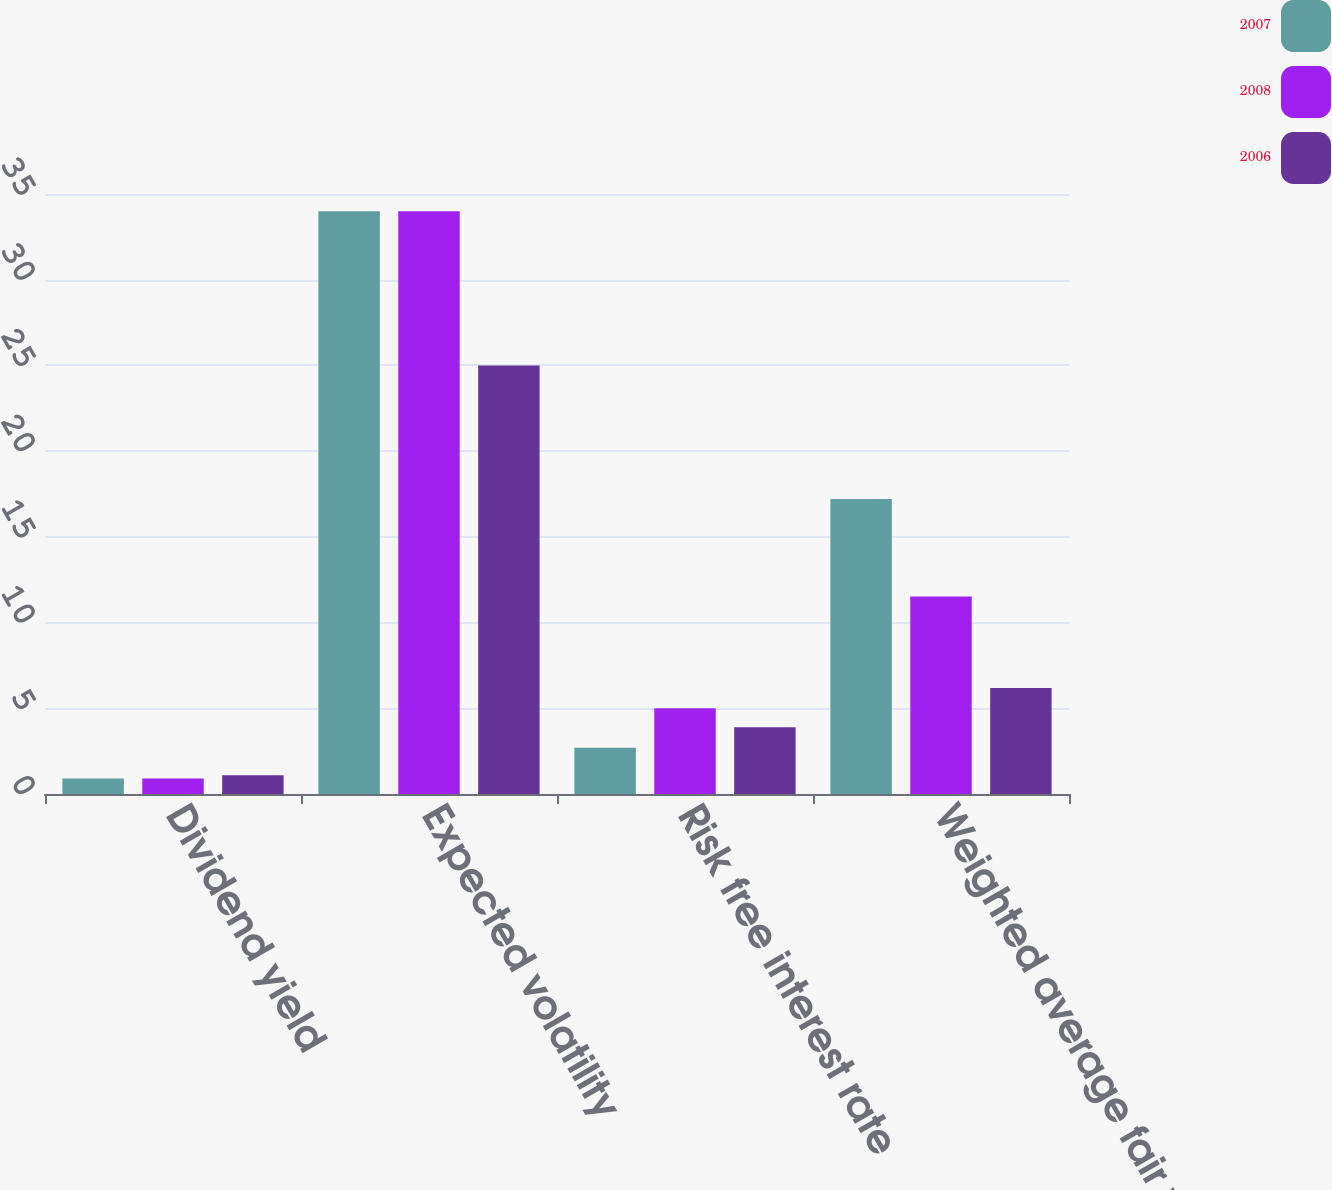Convert chart to OTSL. <chart><loc_0><loc_0><loc_500><loc_500><stacked_bar_chart><ecel><fcel>Dividend yield<fcel>Expected volatility<fcel>Risk free interest rate<fcel>Weighted average fair value<nl><fcel>2007<fcel>0.9<fcel>34<fcel>2.7<fcel>17.21<nl><fcel>2008<fcel>0.9<fcel>34<fcel>5<fcel>11.52<nl><fcel>2006<fcel>1.1<fcel>25<fcel>3.9<fcel>6.19<nl></chart> 